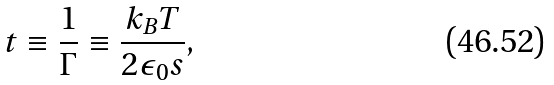Convert formula to latex. <formula><loc_0><loc_0><loc_500><loc_500>t \equiv \frac { 1 } { \Gamma } \equiv \frac { k _ { B } T } { 2 \epsilon _ { 0 } s } ,</formula> 